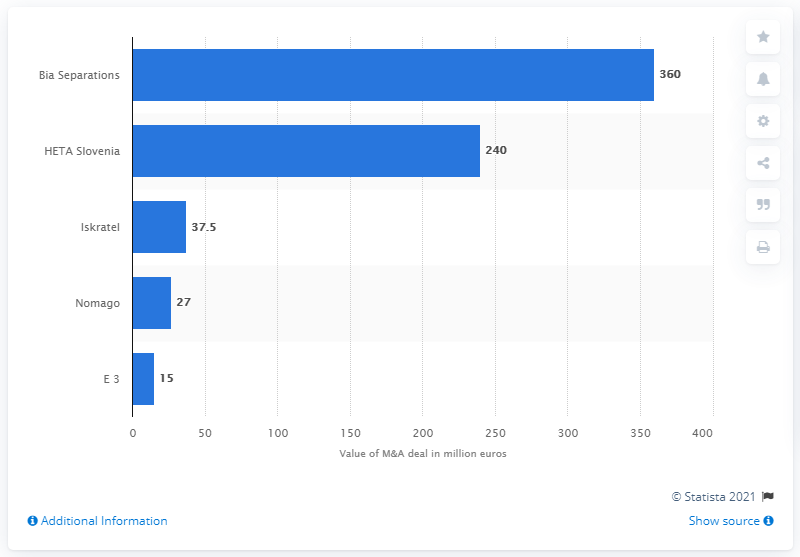Highlight a few significant elements in this photo. The acquisition of Bia Separations was priced at 360... MK Group paid 240.. for HETA Slovenia. 